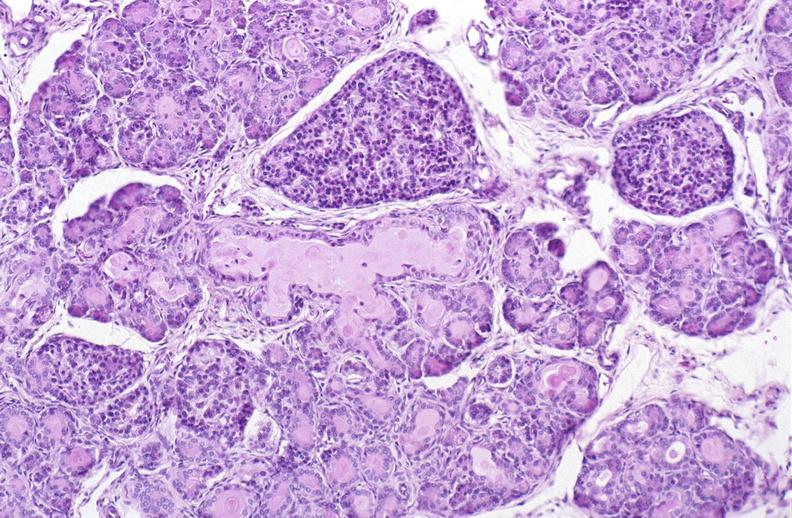does myoma lesion show cystic fibrosis?
Answer the question using a single word or phrase. No 